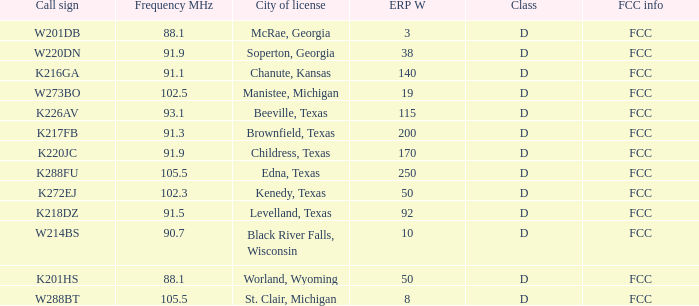What is the aggregate of erp w, when call sign is k216ga? 140.0. 